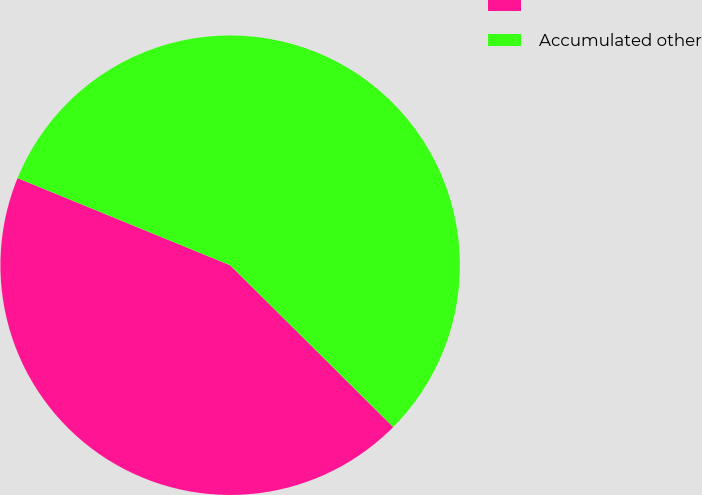Convert chart to OTSL. <chart><loc_0><loc_0><loc_500><loc_500><pie_chart><ecel><fcel>Accumulated other<nl><fcel>43.75%<fcel>56.25%<nl></chart> 